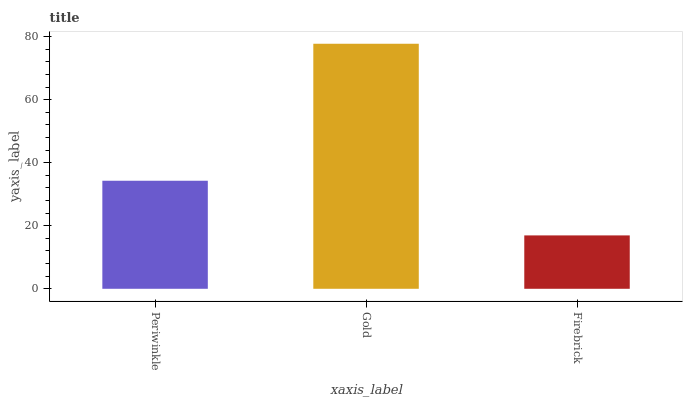Is Firebrick the minimum?
Answer yes or no. Yes. Is Gold the maximum?
Answer yes or no. Yes. Is Gold the minimum?
Answer yes or no. No. Is Firebrick the maximum?
Answer yes or no. No. Is Gold greater than Firebrick?
Answer yes or no. Yes. Is Firebrick less than Gold?
Answer yes or no. Yes. Is Firebrick greater than Gold?
Answer yes or no. No. Is Gold less than Firebrick?
Answer yes or no. No. Is Periwinkle the high median?
Answer yes or no. Yes. Is Periwinkle the low median?
Answer yes or no. Yes. Is Firebrick the high median?
Answer yes or no. No. Is Firebrick the low median?
Answer yes or no. No. 